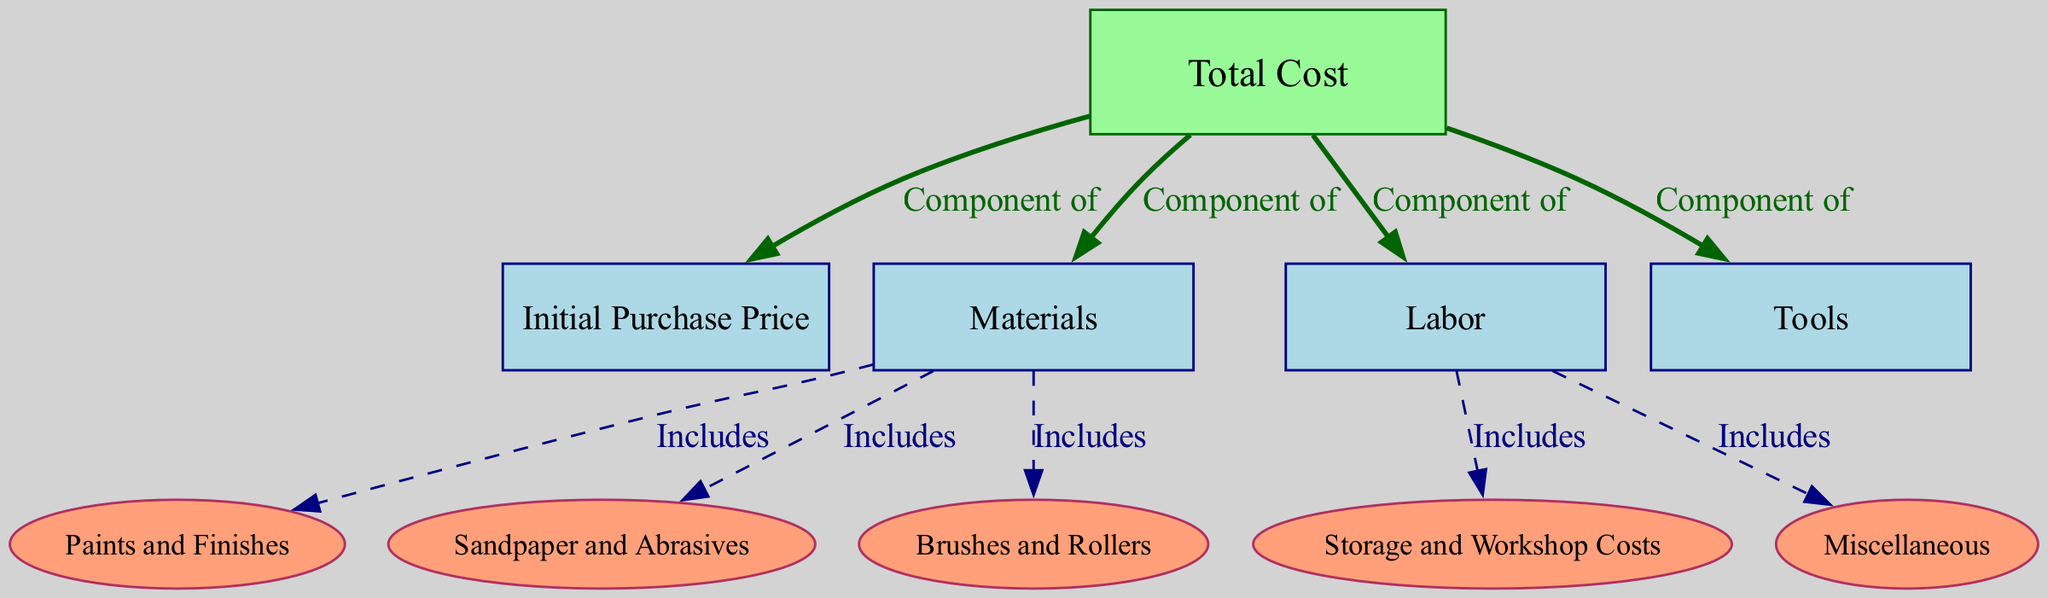What is the main category represented in this diagram? The main category represented at the top of the diagram is labeled "Total Cost." This is indicated by the node with the id "1."
Answer: Total Cost How many total nodes are present in the diagram? The diagram consists of 10 nodes. Each node is counted separately, and the nodes include Total Cost, Initial Purchase Price, Materials, Labor, Tools, Paints and Finishes, Sandpaper and Abrasives, Brushes and Rollers, Storage and Workshop Costs, and Miscellaneous.
Answer: 10 What does "Materials" include according to the diagram? The "Materials" node, id "3," is connected to three other nodes: "Paints and Finishes," "Sandpaper and Abrasives," and "Brushes and Rollers." This indicates that these three components are included in "Materials."
Answer: Paints and Finishes, Sandpaper and Abrasives, Brushes and Rollers Which components are part of the Labor category? The "Labor" node, id "4," connects to "Storage and Workshop Costs" and "Miscellaneous," indicating these components are considered part of the Labor costs in the context of refinishing.
Answer: Storage and Workshop Costs, Miscellaneous What are the direct components that make up the Total Cost? The "Total Cost" node connects directly to four nodes: "Initial Purchase Price," "Materials," "Labor," and "Tools." This denotes these four items as direct components of the Total Cost.
Answer: Initial Purchase Price, Materials, Labor, Tools Which node utilizes a dashed edge connection in the diagram? The edges leading from the "Materials" and "Labor" nodes to their respective subcomponents use a dashed line, indicating that these connections represent inclusion rather than direct components. The nodes "Paints and Finishes," "Sandpaper and Abrasives," "Brushes and Rollers," "Storage and Workshop Costs," and "Miscellaneous" all have dashed edges.
Answer: Paints and Finishes, Sandpaper and Abrasives, Brushes and Rollers, Storage and Workshop Costs, Miscellaneous What color represents the "Total Cost" node in the diagram? The "Total Cost" node is filled with a dark green color, which visually distinguishes it from the other nodes, highlighting its primary importance in the diagram structure.
Answer: Dark Green Which category includes "Tools"? The "Tools" node, with id "5," connects directly to "Total Cost," showing that it is categorized as a component of the Total Cost involved in refinishing.
Answer: Total Cost 